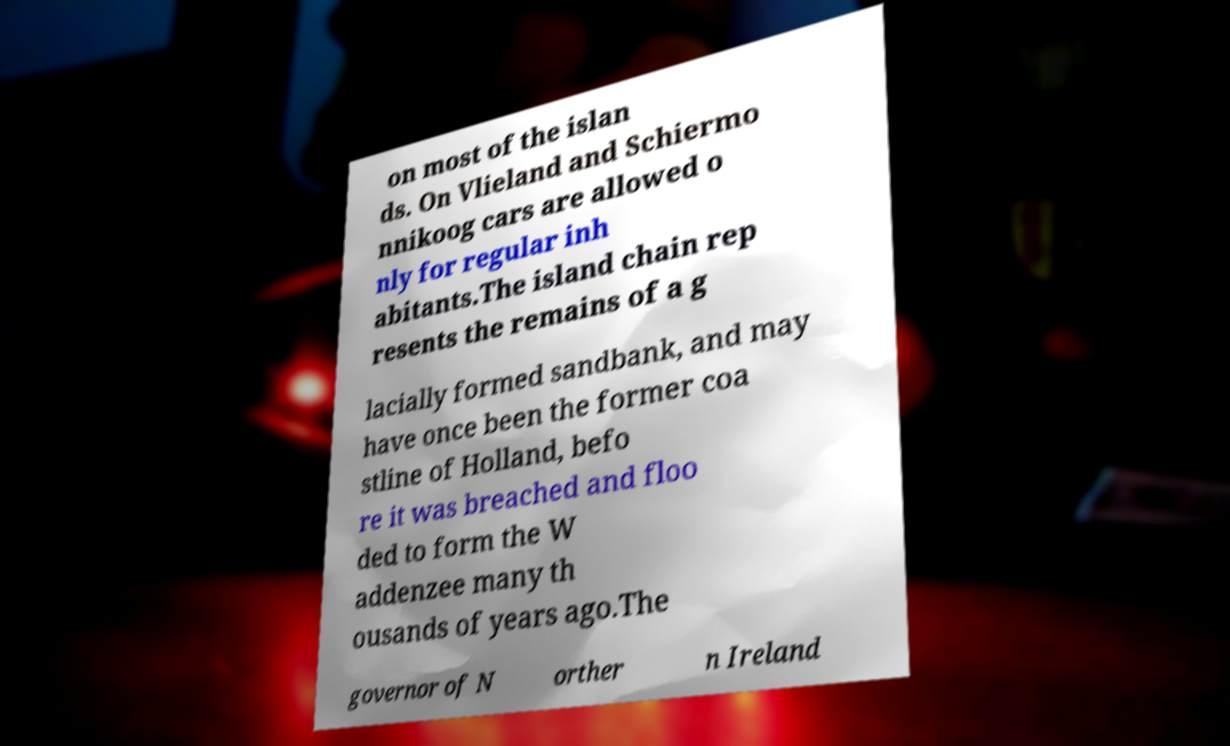Please identify and transcribe the text found in this image. on most of the islan ds. On Vlieland and Schiermo nnikoog cars are allowed o nly for regular inh abitants.The island chain rep resents the remains of a g lacially formed sandbank, and may have once been the former coa stline of Holland, befo re it was breached and floo ded to form the W addenzee many th ousands of years ago.The governor of N orther n Ireland 